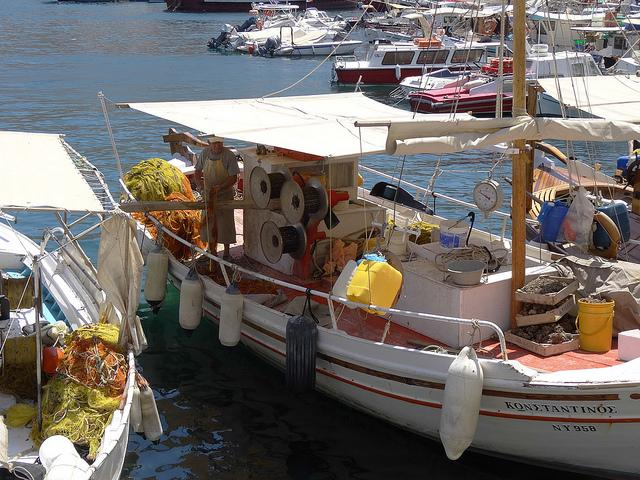What sort of method is used to secure these vessels to the shore? rope 